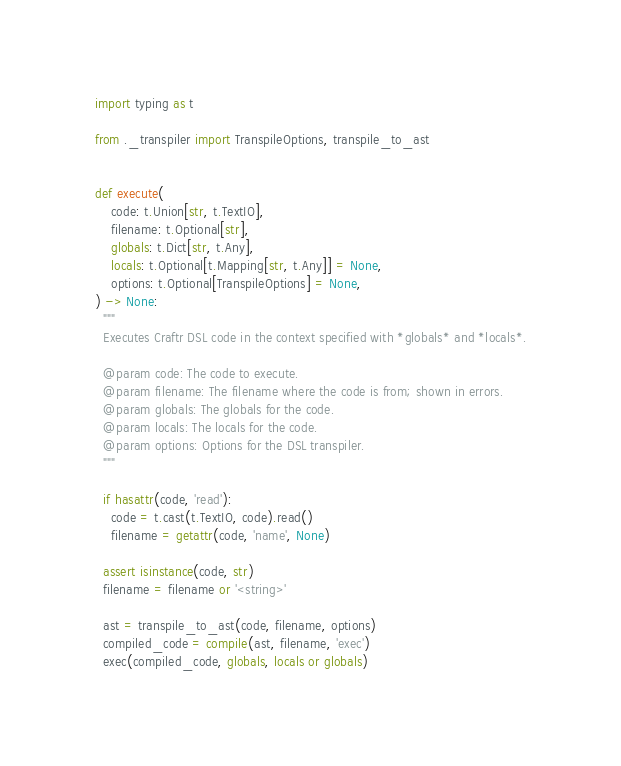<code> <loc_0><loc_0><loc_500><loc_500><_Python_>import typing as t

from ._transpiler import TranspileOptions, transpile_to_ast


def execute(
    code: t.Union[str, t.TextIO],
    filename: t.Optional[str],
    globals: t.Dict[str, t.Any],
    locals: t.Optional[t.Mapping[str, t.Any]] = None,
    options: t.Optional[TranspileOptions] = None,
) -> None:
  """
  Executes Craftr DSL code in the context specified with *globals* and *locals*.

  @param code: The code to execute.
  @param filename: The filename where the code is from; shown in errors.
  @param globals: The globals for the code.
  @param locals: The locals for the code.
  @param options: Options for the DSL transpiler.
  """

  if hasattr(code, 'read'):
    code = t.cast(t.TextIO, code).read()
    filename = getattr(code, 'name', None)

  assert isinstance(code, str)
  filename = filename or '<string>'

  ast = transpile_to_ast(code, filename, options)
  compiled_code = compile(ast, filename, 'exec')
  exec(compiled_code, globals, locals or globals)
</code> 